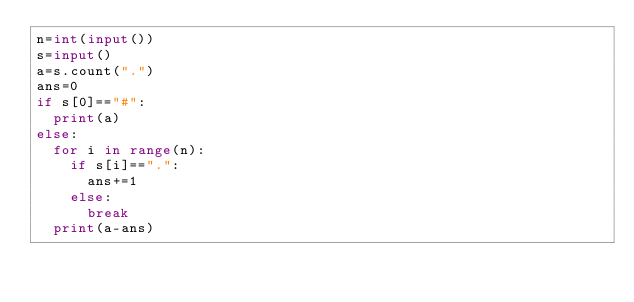Convert code to text. <code><loc_0><loc_0><loc_500><loc_500><_Python_>n=int(input())
s=input()
a=s.count(".")
ans=0
if s[0]=="#":
  print(a)
else:
  for i in range(n):
    if s[i]==".":
      ans+=1
    else:
      break
  print(a-ans)</code> 